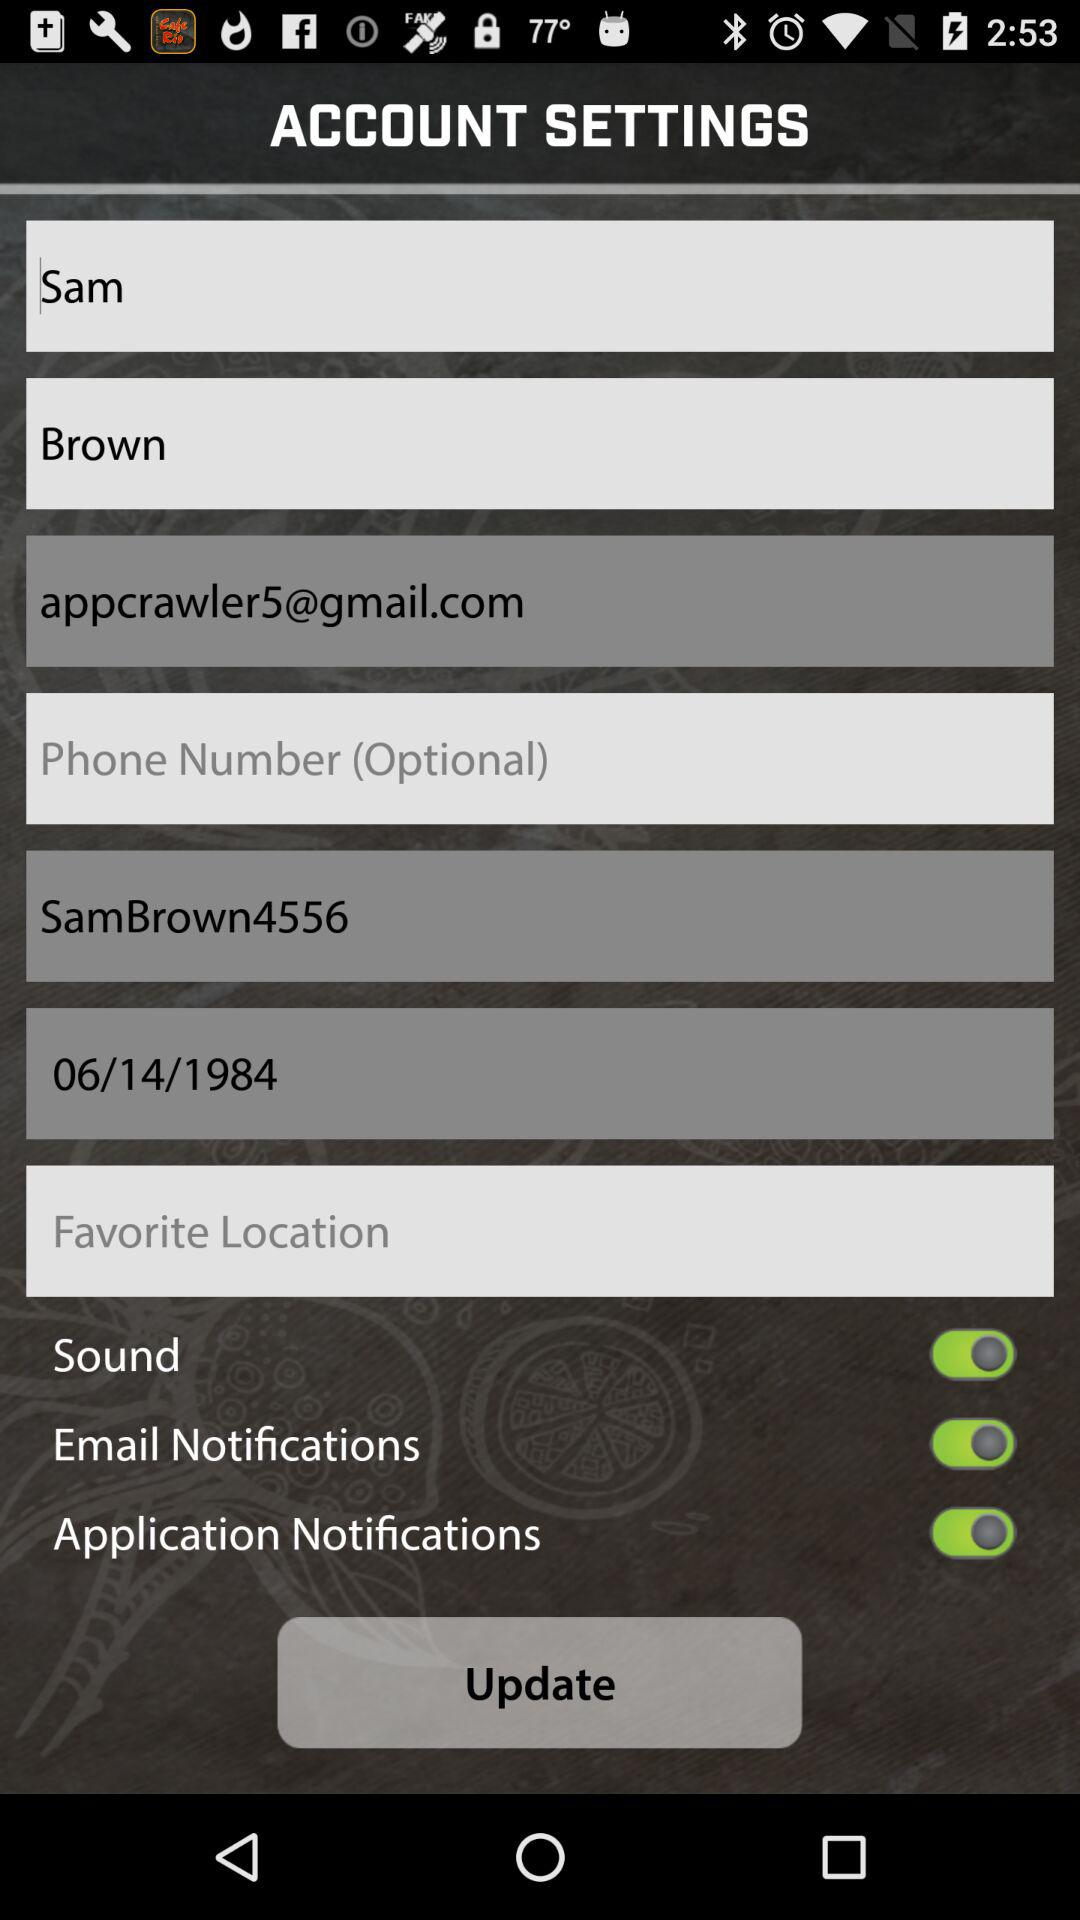What is the given email address? The given email address is appcrawler5@gmail.com. 